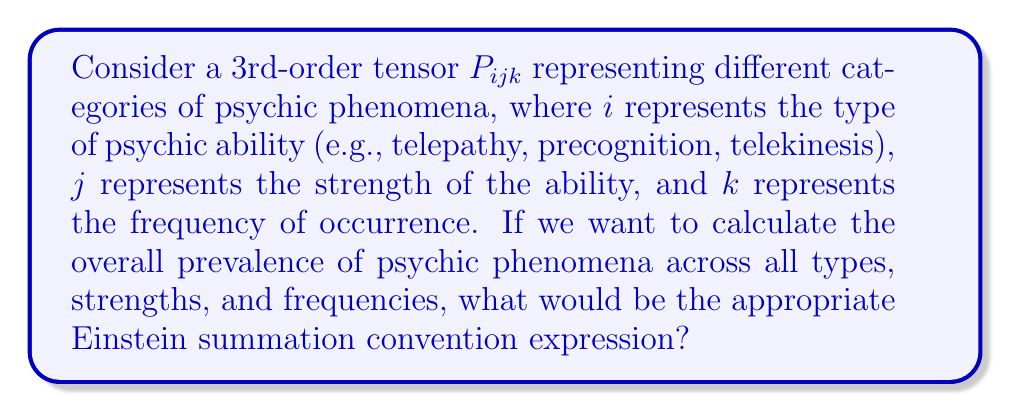Solve this math problem. To solve this problem, let's follow these steps:

1) The Einstein summation convention states that when an index appears twice in a term, once as an upper index and once as a lower index, it implies summation over that index.

2) In our case, we want to sum over all three indices ($i$, $j$, and $k$) to get the overall prevalence of psychic phenomena.

3) To represent this summation, we need to contract the tensor $P_{ijk}$ with itself over all indices.

4) In Einstein notation, repeated indices imply summation. Therefore, we need to write the expression in a way that each index appears twice.

5) The simplest way to do this is to multiply the tensor by itself, with all indices raised:

   $$P_{ijk}P^{ijk}$$

6) This expression implies summation over all $i$, $j$, and $k$, effectively adding up all elements of the tensor.

7) The result will be a scalar value representing the overall prevalence of psychic phenomena across all types, strengths, and frequencies.
Answer: $P_{ijk}P^{ijk}$ 